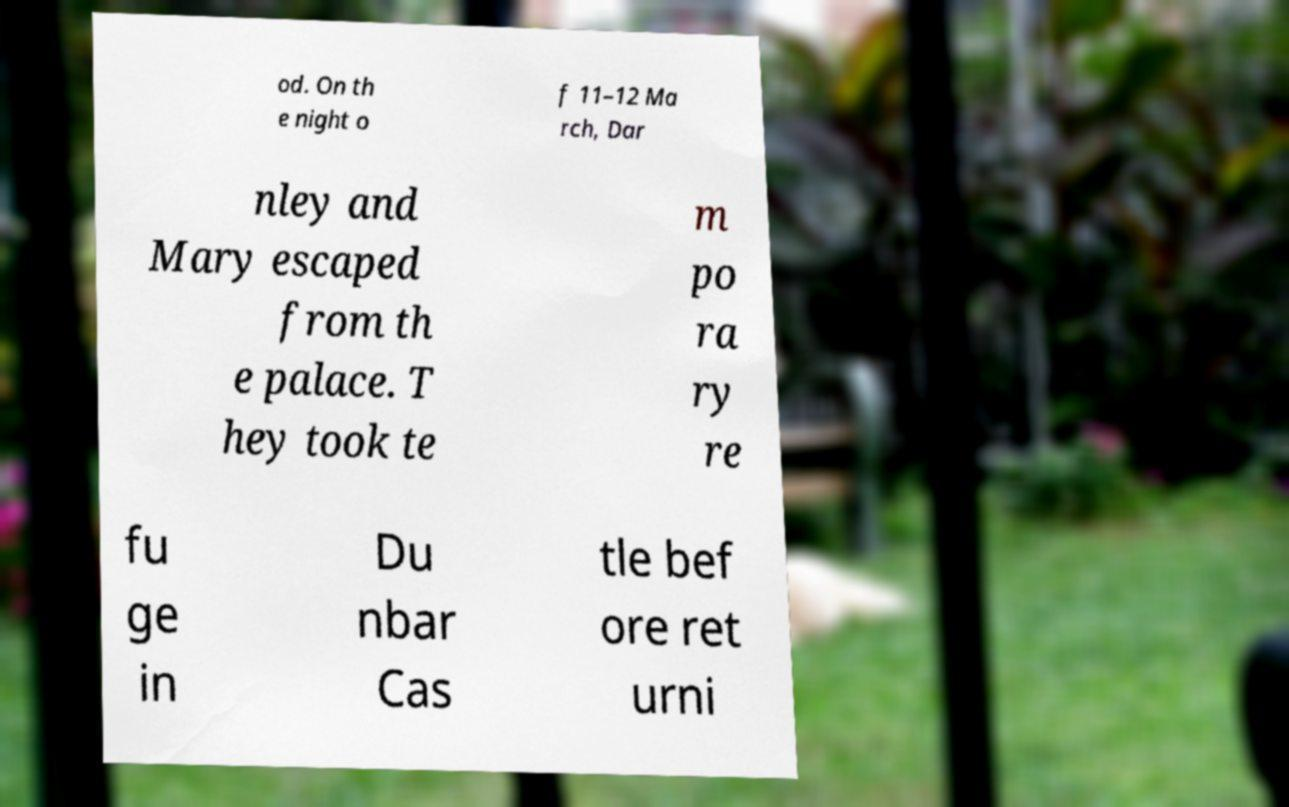Please read and relay the text visible in this image. What does it say? od. On th e night o f 11–12 Ma rch, Dar nley and Mary escaped from th e palace. T hey took te m po ra ry re fu ge in Du nbar Cas tle bef ore ret urni 